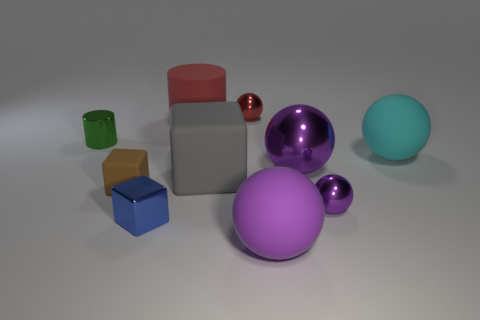Subtract all yellow cubes. How many purple spheres are left? 3 Subtract 3 balls. How many balls are left? 2 Subtract all red balls. How many balls are left? 4 Subtract all tiny red metallic balls. How many balls are left? 4 Subtract all green balls. Subtract all blue blocks. How many balls are left? 5 Subtract all cylinders. How many objects are left? 8 Subtract all small blue metallic cubes. Subtract all green metal cylinders. How many objects are left? 8 Add 7 cubes. How many cubes are left? 10 Add 9 blue objects. How many blue objects exist? 10 Subtract 0 purple blocks. How many objects are left? 10 